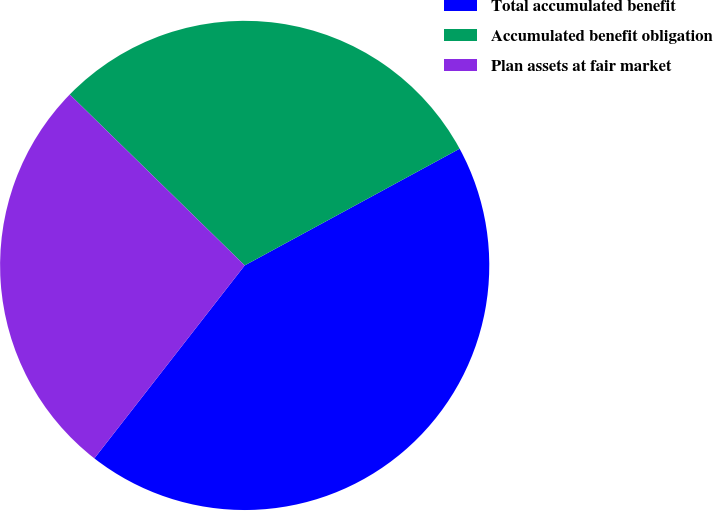<chart> <loc_0><loc_0><loc_500><loc_500><pie_chart><fcel>Total accumulated benefit<fcel>Accumulated benefit obligation<fcel>Plan assets at fair market<nl><fcel>43.45%<fcel>29.77%<fcel>26.78%<nl></chart> 